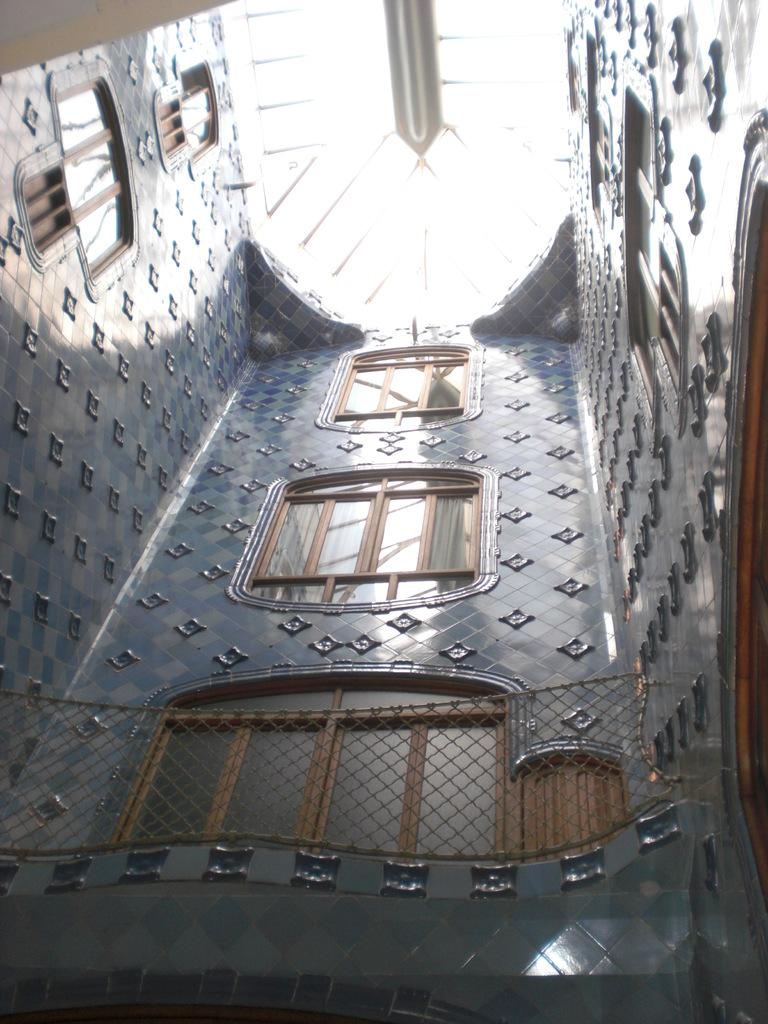What type of location is depicted in the image? The image shows an inside view of a building. What architectural feature can be seen in the image? There are windows visible in the image. What is the purpose of the fence in the image? The purpose of the fence in the image is not specified, but it could be used for decoration or to separate different areas within the building. How many oranges are on the tray in the image? There is no tray or oranges present in the image. 